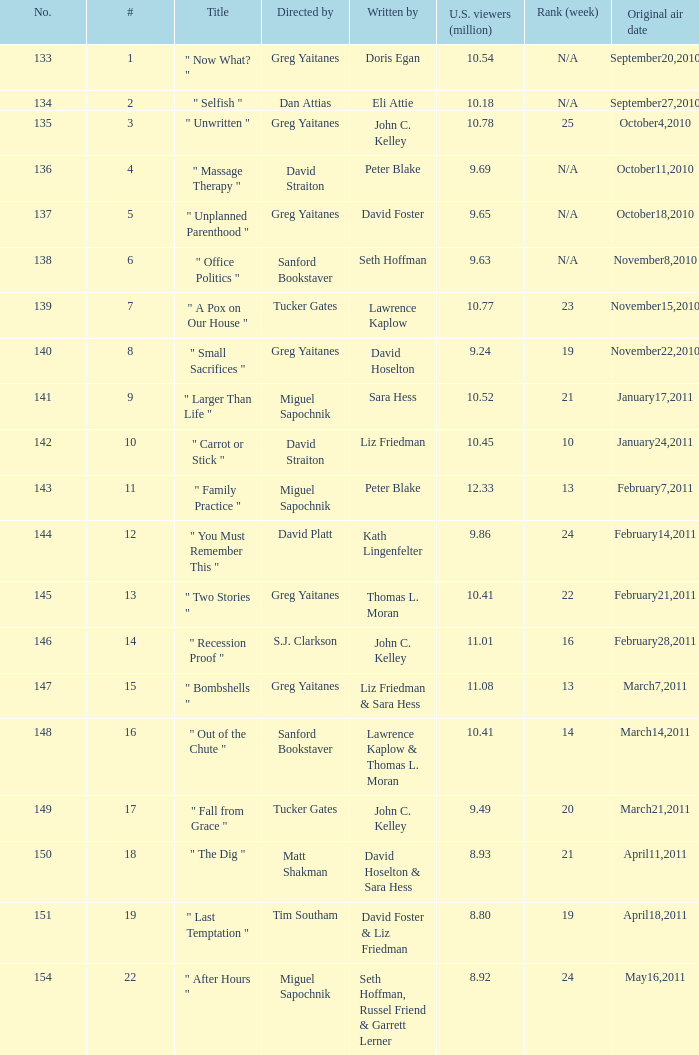How many episodes were written by seth hoffman, russel friend & garrett lerner? 1.0. 